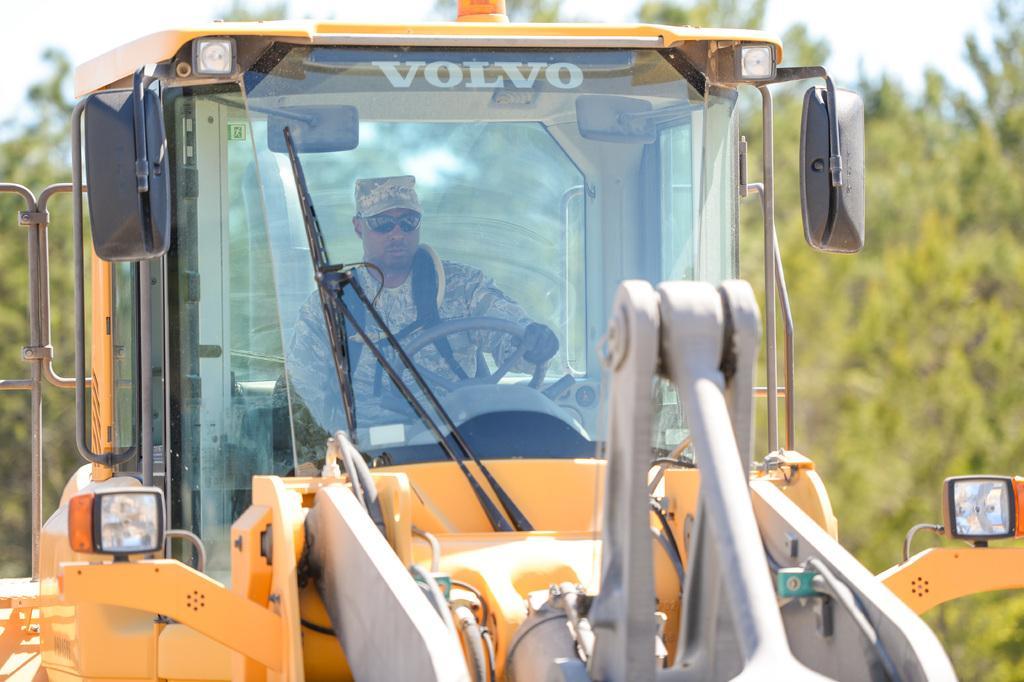Please provide a concise description of this image. In this picture we can see a man wore goggles, cap and gloves to his hand and holding steering in his hand and driving the excavator and at the background we can see sky, trees. 